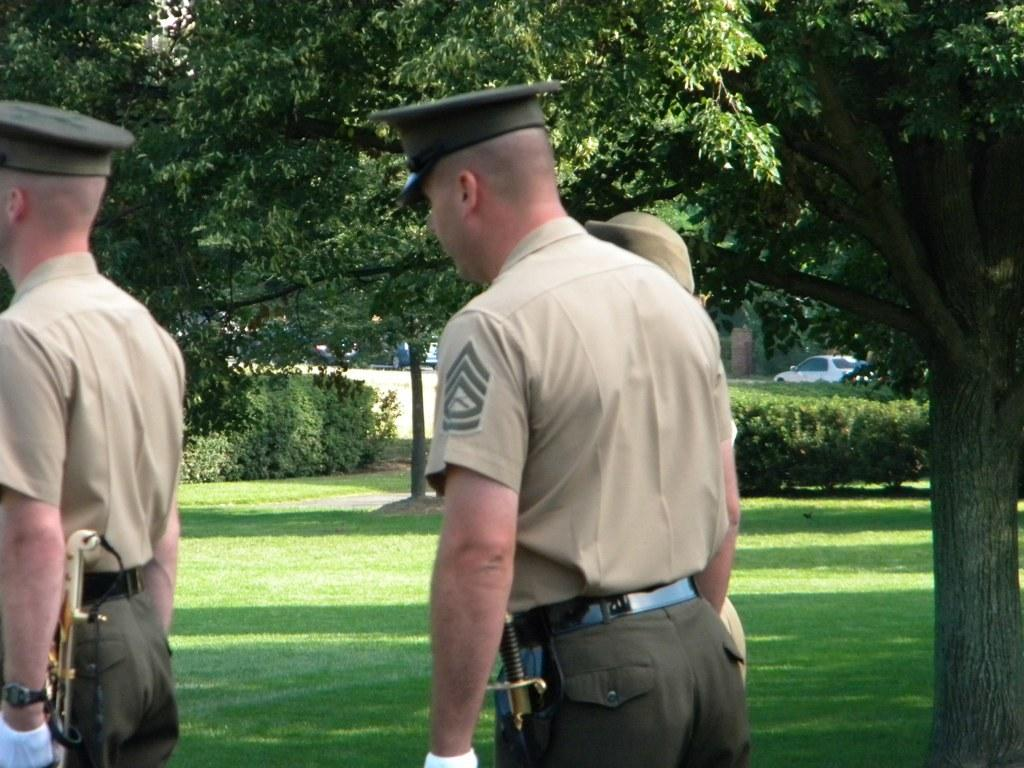What is the setting of the image? There are people on a grassland in the image. What can be seen on the right side of the image? There is a tree on the right side of the image. What type of vegetation is visible in the background of the image? There are plants visible in the background of the image. What else can be seen in the background of the image? There are cars on a road in the background of the image. What verse is being recited by the clam in the image? There is no clam or verse present in the image; it features people on a grassland with a tree and plants in the background. Can you tell me the relationship between the people and the aunt in the image? There is no mention of an aunt in the image; it only features people on a grassland with a tree and plants in the background. 